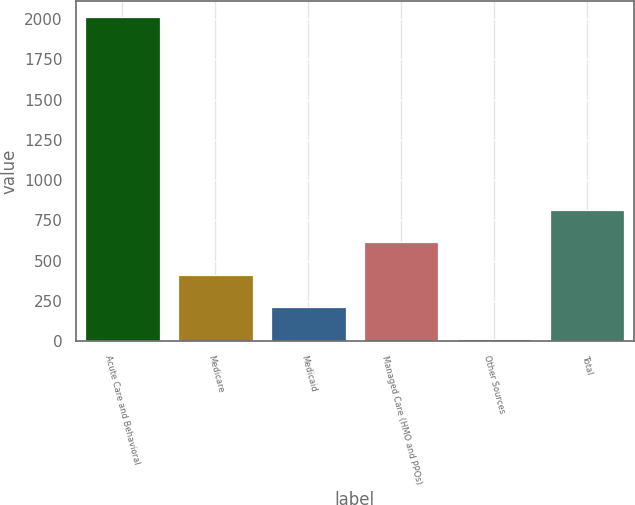Convert chart to OTSL. <chart><loc_0><loc_0><loc_500><loc_500><bar_chart><fcel>Acute Care and Behavioral<fcel>Medicare<fcel>Medicaid<fcel>Managed Care (HMO and PPOs)<fcel>Other Sources<fcel>Total<nl><fcel>2013<fcel>413<fcel>213<fcel>613<fcel>13<fcel>813<nl></chart> 